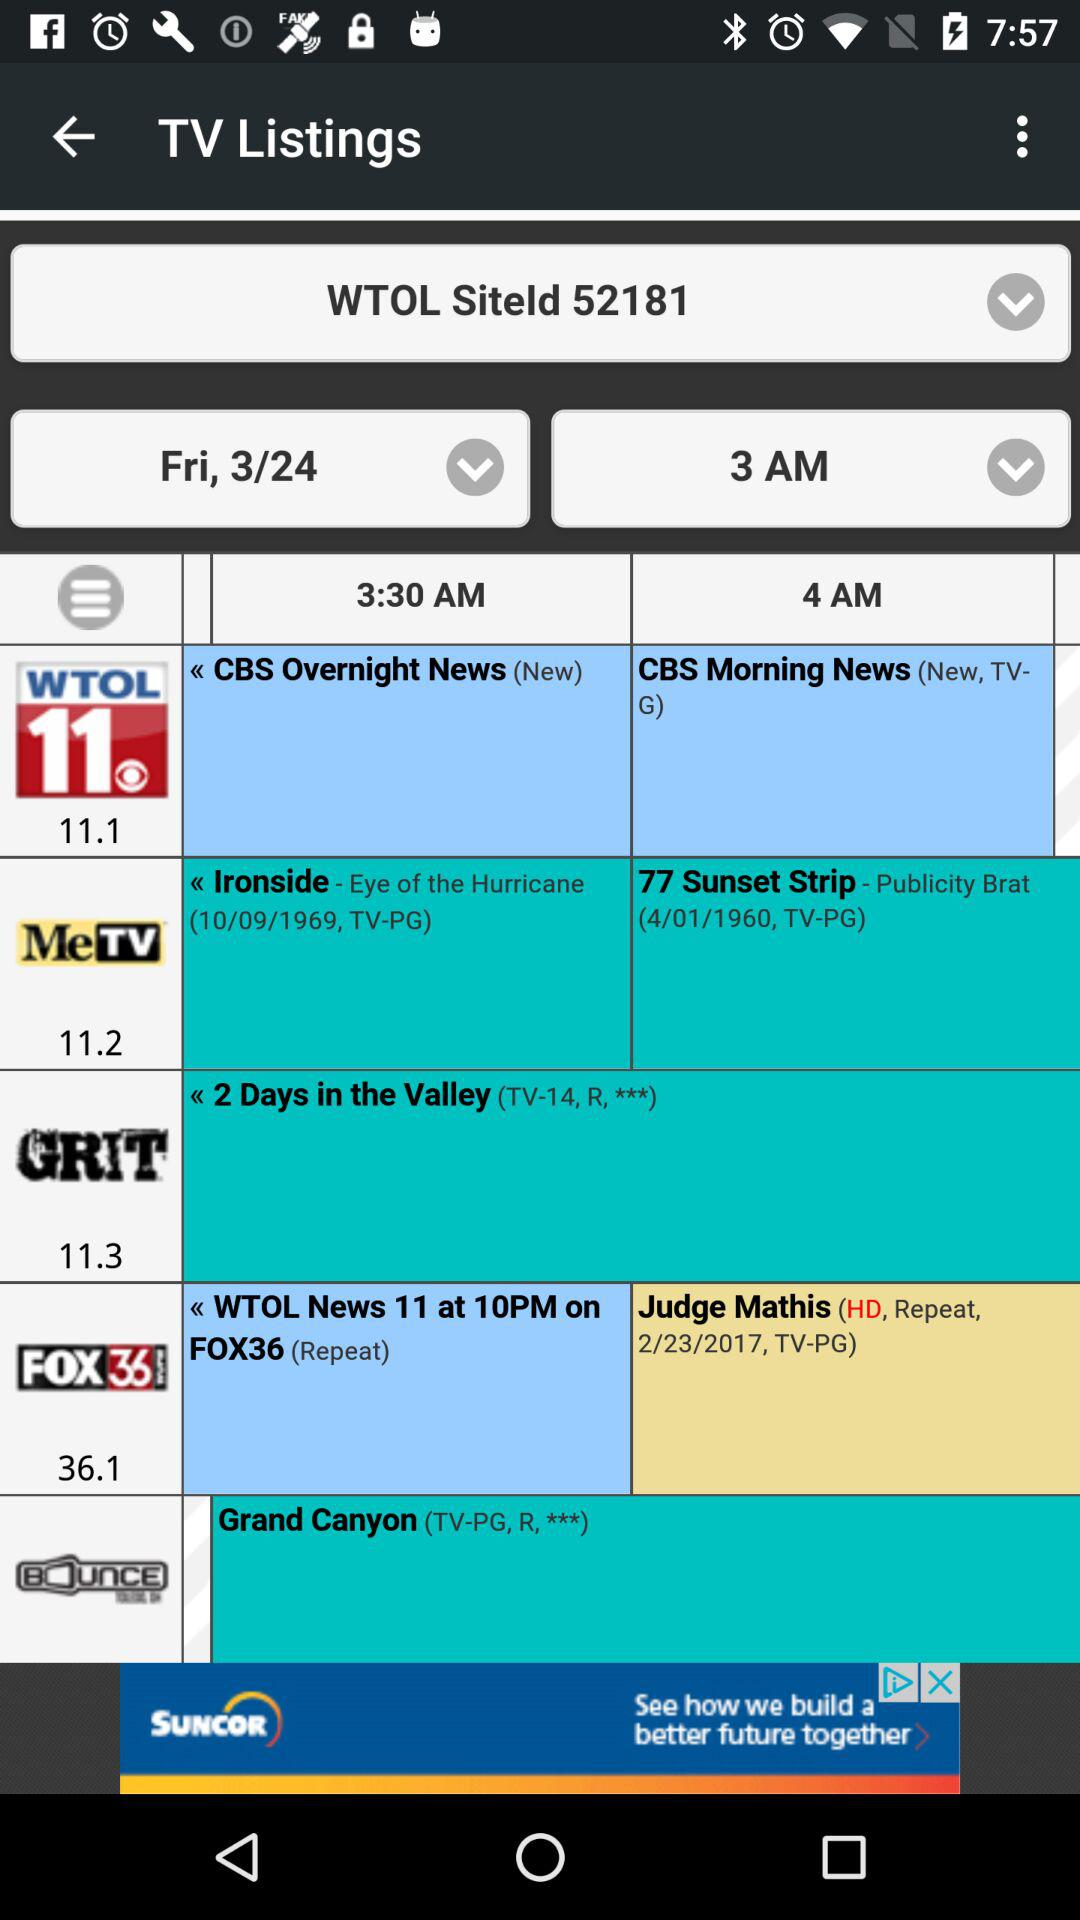What is the date and time for "WTOL siteld 52181"? The date and time are Friday, March 24 and 3 AM. 